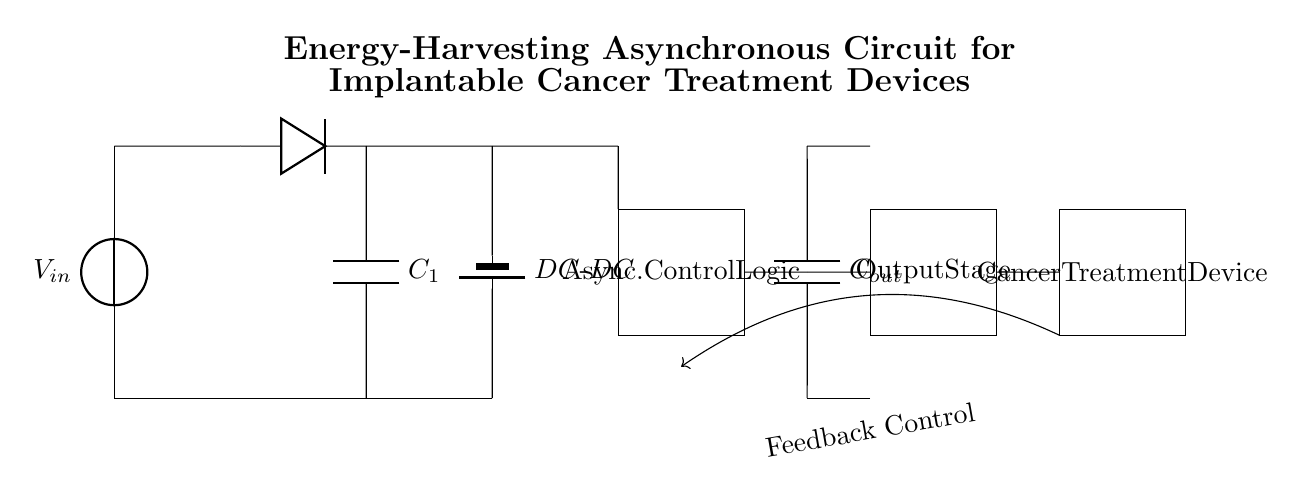What is the input voltage of the circuit? The diagram shows a labeled voltage source, denoted as V_in, representing the input voltage.
Answer: V in What type of diode is used in this circuit? The circuit diagram shows a standard diode symbol, which indicates that a conventional silicon diode is used.
Answer: Diode How many capacitors are present in the circuit? There are two capacitors labeled as C_1 and C_out in the diagram, clearly identifiable by their symbols and labels.
Answer: 2 What is the role of the battery marked DC-DC? The DC-DC converter is used to regulate the voltage level within the circuit, ensuring the output is appropriate for the subsequent stages.
Answer: Voltage regulation What function does the asynchronous control logic serve? The asynchronous control logic is responsible for managing the timing and operation of the circuit, allowing it to function independently without a clock signal.
Answer: Timing and management How does feedback in this circuit operate? Feedback is indicated by an arrow pointing from the load back to the control logic, suggesting that it monitors and adjusts the circuit based on the load conditions for optimal performance.
Answer: Monitoring and adjustment 